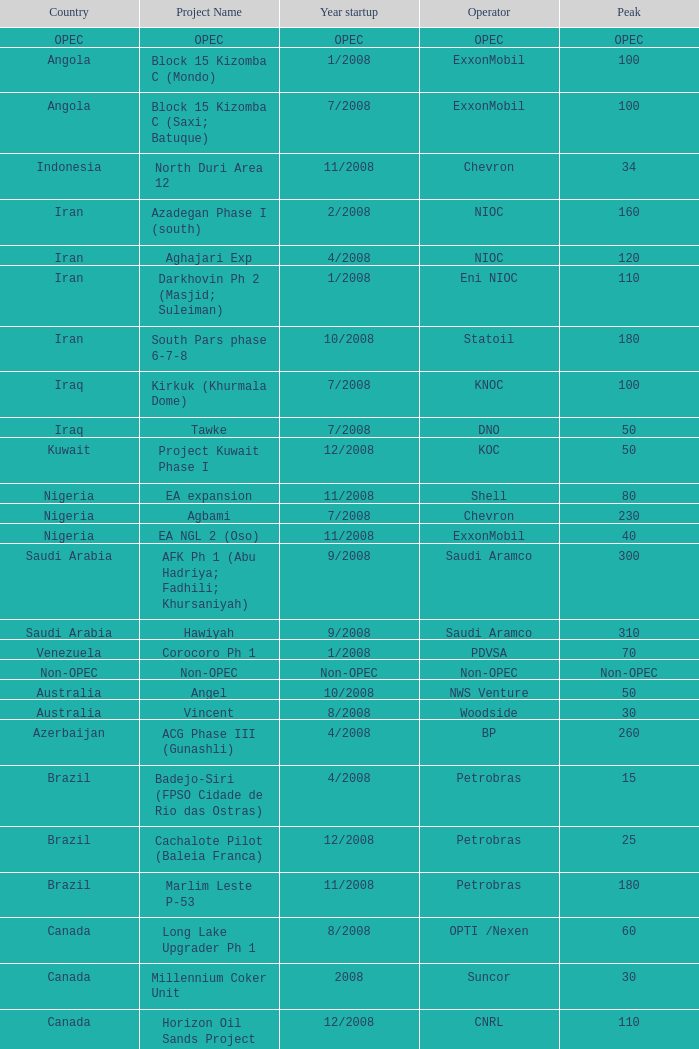Which peak corresponds to the project called talakan ph 1? 60.0. 